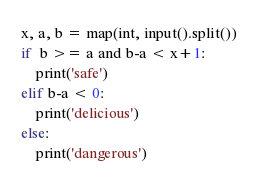<code> <loc_0><loc_0><loc_500><loc_500><_Python_>x, a, b = map(int, input().split())
if  b >= a and b-a < x+1:
    print('safe')
elif b-a < 0:
    print('delicious')
else:
    print('dangerous')</code> 